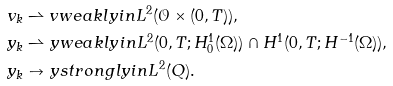Convert formula to latex. <formula><loc_0><loc_0><loc_500><loc_500>& v _ { k } \rightharpoonup v w e a k l y i n L ^ { 2 } ( \mathcal { O } \times ( 0 , T ) ) , \\ & y _ { k } \rightharpoonup y w e a k l y i n L ^ { 2 } ( 0 , T ; H ^ { 1 } _ { 0 } ( \Omega ) ) \cap H ^ { 1 } ( 0 , T ; H ^ { - 1 } ( \Omega ) ) , \\ & y _ { k } \to y s t r o n g l y i n L ^ { 2 } ( Q ) .</formula> 